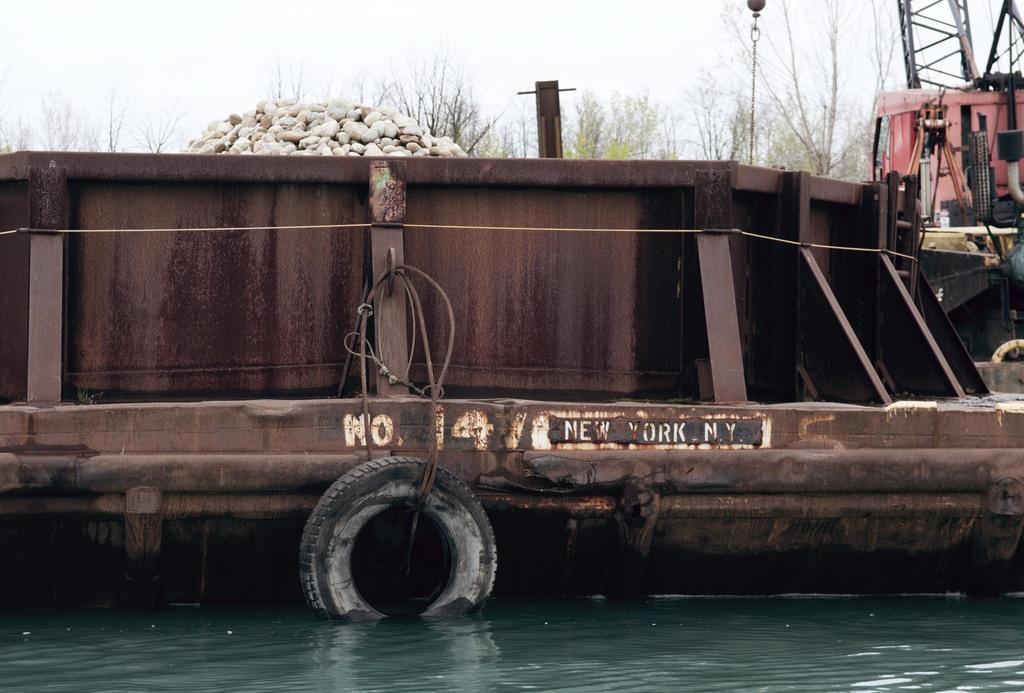In one or two sentences, can you explain what this image depicts? In this image there is a old onkay puls boat on the river, behind that there are rocks, trees and the sky. 